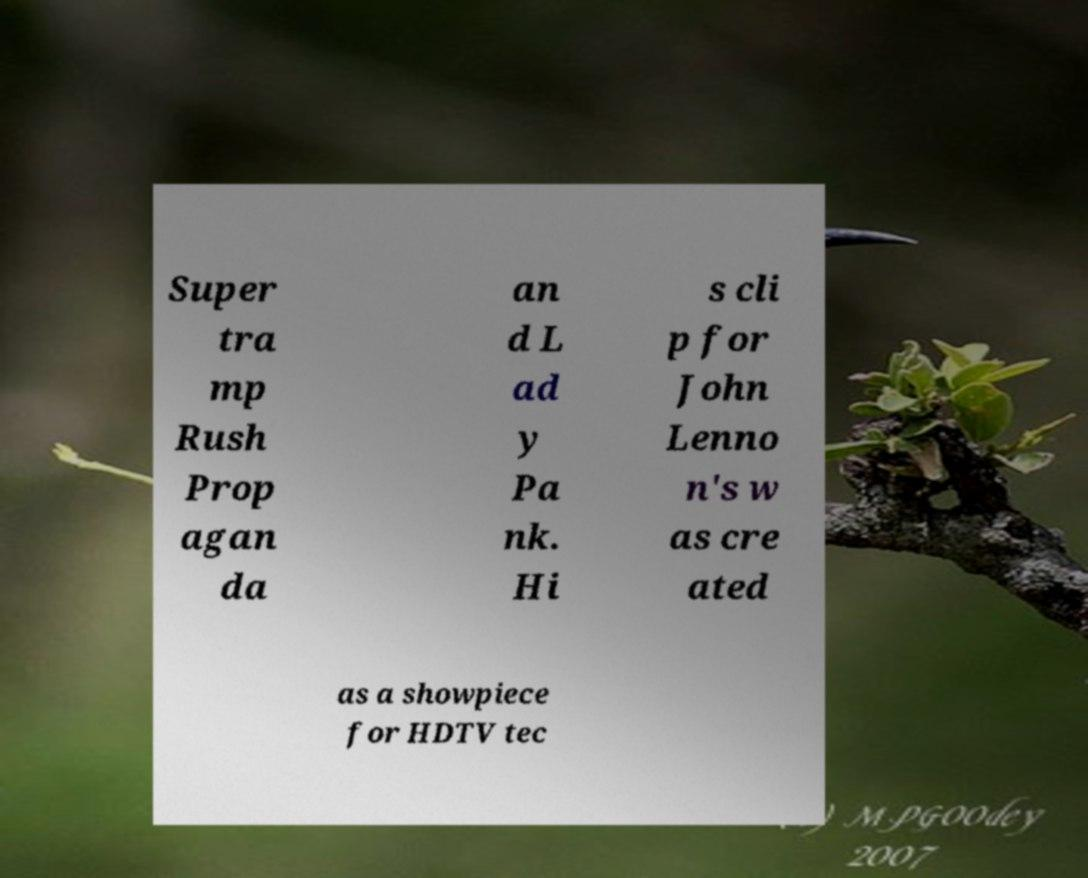Can you read and provide the text displayed in the image?This photo seems to have some interesting text. Can you extract and type it out for me? Super tra mp Rush Prop agan da an d L ad y Pa nk. Hi s cli p for John Lenno n's w as cre ated as a showpiece for HDTV tec 